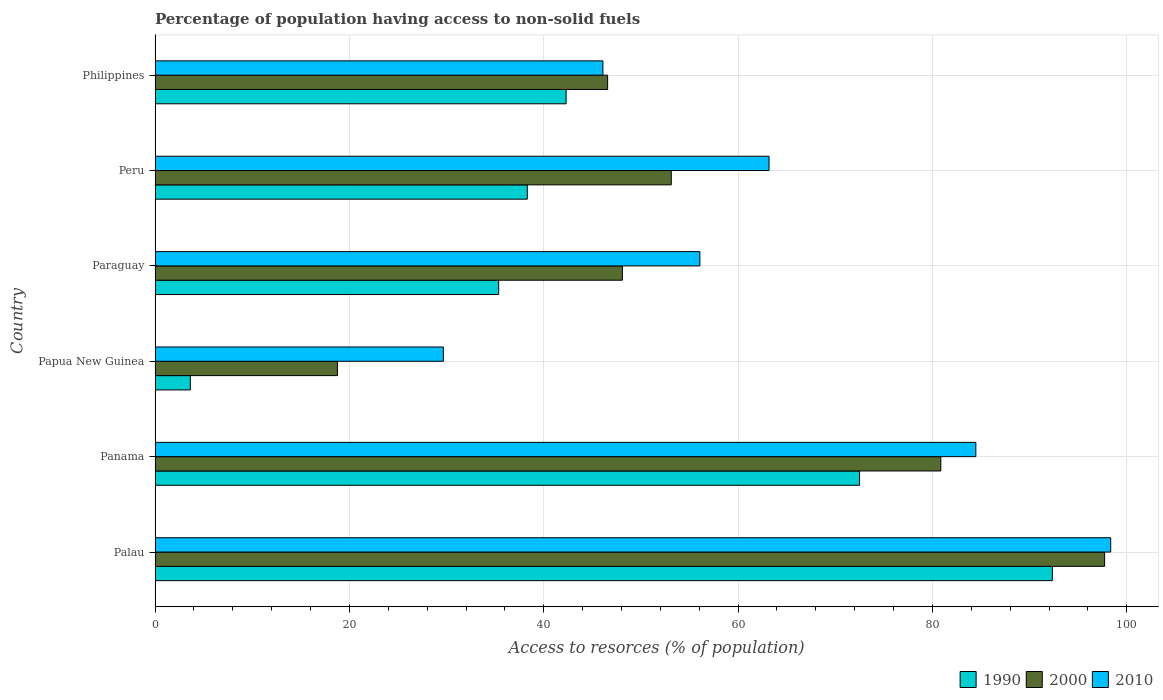How many different coloured bars are there?
Keep it short and to the point. 3. How many groups of bars are there?
Give a very brief answer. 6. Are the number of bars on each tick of the Y-axis equal?
Keep it short and to the point. Yes. How many bars are there on the 1st tick from the top?
Offer a terse response. 3. How many bars are there on the 5th tick from the bottom?
Your response must be concise. 3. What is the label of the 1st group of bars from the top?
Offer a terse response. Philippines. In how many cases, is the number of bars for a given country not equal to the number of legend labels?
Your response must be concise. 0. What is the percentage of population having access to non-solid fuels in 2000 in Peru?
Provide a succinct answer. 53.13. Across all countries, what is the maximum percentage of population having access to non-solid fuels in 2010?
Your answer should be compact. 98.35. Across all countries, what is the minimum percentage of population having access to non-solid fuels in 2010?
Your answer should be compact. 29.67. In which country was the percentage of population having access to non-solid fuels in 2010 maximum?
Ensure brevity in your answer.  Palau. In which country was the percentage of population having access to non-solid fuels in 2010 minimum?
Provide a succinct answer. Papua New Guinea. What is the total percentage of population having access to non-solid fuels in 1990 in the graph?
Keep it short and to the point. 284.46. What is the difference between the percentage of population having access to non-solid fuels in 2010 in Palau and that in Paraguay?
Make the answer very short. 42.28. What is the difference between the percentage of population having access to non-solid fuels in 1990 in Palau and the percentage of population having access to non-solid fuels in 2000 in Paraguay?
Provide a short and direct response. 44.25. What is the average percentage of population having access to non-solid fuels in 2000 per country?
Provide a short and direct response. 57.53. What is the difference between the percentage of population having access to non-solid fuels in 2010 and percentage of population having access to non-solid fuels in 2000 in Palau?
Provide a short and direct response. 0.63. What is the ratio of the percentage of population having access to non-solid fuels in 2010 in Palau to that in Philippines?
Offer a terse response. 2.13. What is the difference between the highest and the second highest percentage of population having access to non-solid fuels in 2010?
Your answer should be compact. 13.88. What is the difference between the highest and the lowest percentage of population having access to non-solid fuels in 2000?
Your answer should be compact. 78.95. What does the 3rd bar from the top in Panama represents?
Keep it short and to the point. 1990. What does the 3rd bar from the bottom in Palau represents?
Offer a very short reply. 2010. Is it the case that in every country, the sum of the percentage of population having access to non-solid fuels in 1990 and percentage of population having access to non-solid fuels in 2010 is greater than the percentage of population having access to non-solid fuels in 2000?
Provide a short and direct response. Yes. What is the difference between two consecutive major ticks on the X-axis?
Keep it short and to the point. 20. Does the graph contain any zero values?
Give a very brief answer. No. Where does the legend appear in the graph?
Your answer should be very brief. Bottom right. How many legend labels are there?
Provide a short and direct response. 3. How are the legend labels stacked?
Provide a succinct answer. Horizontal. What is the title of the graph?
Make the answer very short. Percentage of population having access to non-solid fuels. What is the label or title of the X-axis?
Ensure brevity in your answer.  Access to resorces (% of population). What is the Access to resorces (% of population) of 1990 in Palau?
Provide a short and direct response. 92.34. What is the Access to resorces (% of population) in 2000 in Palau?
Your answer should be very brief. 97.72. What is the Access to resorces (% of population) of 2010 in Palau?
Ensure brevity in your answer.  98.35. What is the Access to resorces (% of population) of 1990 in Panama?
Provide a short and direct response. 72.5. What is the Access to resorces (% of population) in 2000 in Panama?
Offer a terse response. 80.86. What is the Access to resorces (% of population) of 2010 in Panama?
Ensure brevity in your answer.  84.47. What is the Access to resorces (% of population) in 1990 in Papua New Guinea?
Keep it short and to the point. 3.63. What is the Access to resorces (% of population) in 2000 in Papua New Guinea?
Offer a very short reply. 18.77. What is the Access to resorces (% of population) of 2010 in Papua New Guinea?
Make the answer very short. 29.67. What is the Access to resorces (% of population) in 1990 in Paraguay?
Your response must be concise. 35.36. What is the Access to resorces (% of population) in 2000 in Paraguay?
Give a very brief answer. 48.09. What is the Access to resorces (% of population) in 2010 in Paraguay?
Provide a succinct answer. 56.07. What is the Access to resorces (% of population) in 1990 in Peru?
Offer a very short reply. 38.31. What is the Access to resorces (% of population) in 2000 in Peru?
Offer a very short reply. 53.13. What is the Access to resorces (% of population) in 2010 in Peru?
Your answer should be very brief. 63.19. What is the Access to resorces (% of population) in 1990 in Philippines?
Keep it short and to the point. 42.3. What is the Access to resorces (% of population) in 2000 in Philippines?
Provide a succinct answer. 46.58. What is the Access to resorces (% of population) in 2010 in Philippines?
Your answer should be very brief. 46.09. Across all countries, what is the maximum Access to resorces (% of population) in 1990?
Your answer should be very brief. 92.34. Across all countries, what is the maximum Access to resorces (% of population) in 2000?
Provide a short and direct response. 97.72. Across all countries, what is the maximum Access to resorces (% of population) of 2010?
Give a very brief answer. 98.35. Across all countries, what is the minimum Access to resorces (% of population) of 1990?
Provide a short and direct response. 3.63. Across all countries, what is the minimum Access to resorces (% of population) in 2000?
Ensure brevity in your answer.  18.77. Across all countries, what is the minimum Access to resorces (% of population) in 2010?
Make the answer very short. 29.67. What is the total Access to resorces (% of population) of 1990 in the graph?
Provide a succinct answer. 284.46. What is the total Access to resorces (% of population) of 2000 in the graph?
Your answer should be very brief. 345.15. What is the total Access to resorces (% of population) in 2010 in the graph?
Your response must be concise. 377.84. What is the difference between the Access to resorces (% of population) of 1990 in Palau and that in Panama?
Give a very brief answer. 19.84. What is the difference between the Access to resorces (% of population) in 2000 in Palau and that in Panama?
Ensure brevity in your answer.  16.86. What is the difference between the Access to resorces (% of population) in 2010 in Palau and that in Panama?
Your answer should be compact. 13.88. What is the difference between the Access to resorces (% of population) in 1990 in Palau and that in Papua New Guinea?
Your answer should be compact. 88.71. What is the difference between the Access to resorces (% of population) of 2000 in Palau and that in Papua New Guinea?
Ensure brevity in your answer.  78.95. What is the difference between the Access to resorces (% of population) of 2010 in Palau and that in Papua New Guinea?
Your answer should be compact. 68.68. What is the difference between the Access to resorces (% of population) in 1990 in Palau and that in Paraguay?
Ensure brevity in your answer.  56.98. What is the difference between the Access to resorces (% of population) in 2000 in Palau and that in Paraguay?
Make the answer very short. 49.63. What is the difference between the Access to resorces (% of population) in 2010 in Palau and that in Paraguay?
Your answer should be compact. 42.28. What is the difference between the Access to resorces (% of population) of 1990 in Palau and that in Peru?
Your response must be concise. 54.04. What is the difference between the Access to resorces (% of population) of 2000 in Palau and that in Peru?
Make the answer very short. 44.6. What is the difference between the Access to resorces (% of population) of 2010 in Palau and that in Peru?
Make the answer very short. 35.16. What is the difference between the Access to resorces (% of population) in 1990 in Palau and that in Philippines?
Provide a succinct answer. 50.04. What is the difference between the Access to resorces (% of population) of 2000 in Palau and that in Philippines?
Provide a short and direct response. 51.15. What is the difference between the Access to resorces (% of population) in 2010 in Palau and that in Philippines?
Make the answer very short. 52.26. What is the difference between the Access to resorces (% of population) of 1990 in Panama and that in Papua New Guinea?
Provide a succinct answer. 68.87. What is the difference between the Access to resorces (% of population) in 2000 in Panama and that in Papua New Guinea?
Offer a very short reply. 62.09. What is the difference between the Access to resorces (% of population) in 2010 in Panama and that in Papua New Guinea?
Your answer should be compact. 54.8. What is the difference between the Access to resorces (% of population) of 1990 in Panama and that in Paraguay?
Offer a very short reply. 37.14. What is the difference between the Access to resorces (% of population) of 2000 in Panama and that in Paraguay?
Provide a succinct answer. 32.77. What is the difference between the Access to resorces (% of population) in 2010 in Panama and that in Paraguay?
Your answer should be very brief. 28.4. What is the difference between the Access to resorces (% of population) of 1990 in Panama and that in Peru?
Offer a terse response. 34.19. What is the difference between the Access to resorces (% of population) in 2000 in Panama and that in Peru?
Your response must be concise. 27.74. What is the difference between the Access to resorces (% of population) in 2010 in Panama and that in Peru?
Offer a very short reply. 21.28. What is the difference between the Access to resorces (% of population) of 1990 in Panama and that in Philippines?
Your response must be concise. 30.2. What is the difference between the Access to resorces (% of population) in 2000 in Panama and that in Philippines?
Keep it short and to the point. 34.29. What is the difference between the Access to resorces (% of population) in 2010 in Panama and that in Philippines?
Provide a succinct answer. 38.38. What is the difference between the Access to resorces (% of population) in 1990 in Papua New Guinea and that in Paraguay?
Your answer should be compact. -31.73. What is the difference between the Access to resorces (% of population) of 2000 in Papua New Guinea and that in Paraguay?
Make the answer very short. -29.32. What is the difference between the Access to resorces (% of population) of 2010 in Papua New Guinea and that in Paraguay?
Provide a short and direct response. -26.4. What is the difference between the Access to resorces (% of population) of 1990 in Papua New Guinea and that in Peru?
Your answer should be compact. -34.68. What is the difference between the Access to resorces (% of population) in 2000 in Papua New Guinea and that in Peru?
Make the answer very short. -34.35. What is the difference between the Access to resorces (% of population) of 2010 in Papua New Guinea and that in Peru?
Provide a short and direct response. -33.52. What is the difference between the Access to resorces (% of population) of 1990 in Papua New Guinea and that in Philippines?
Your answer should be very brief. -38.67. What is the difference between the Access to resorces (% of population) of 2000 in Papua New Guinea and that in Philippines?
Make the answer very short. -27.8. What is the difference between the Access to resorces (% of population) in 2010 in Papua New Guinea and that in Philippines?
Ensure brevity in your answer.  -16.42. What is the difference between the Access to resorces (% of population) in 1990 in Paraguay and that in Peru?
Provide a succinct answer. -2.95. What is the difference between the Access to resorces (% of population) of 2000 in Paraguay and that in Peru?
Offer a very short reply. -5.03. What is the difference between the Access to resorces (% of population) of 2010 in Paraguay and that in Peru?
Make the answer very short. -7.12. What is the difference between the Access to resorces (% of population) in 1990 in Paraguay and that in Philippines?
Provide a short and direct response. -6.94. What is the difference between the Access to resorces (% of population) of 2000 in Paraguay and that in Philippines?
Your answer should be very brief. 1.52. What is the difference between the Access to resorces (% of population) of 2010 in Paraguay and that in Philippines?
Your response must be concise. 9.98. What is the difference between the Access to resorces (% of population) of 1990 in Peru and that in Philippines?
Give a very brief answer. -4. What is the difference between the Access to resorces (% of population) of 2000 in Peru and that in Philippines?
Keep it short and to the point. 6.55. What is the difference between the Access to resorces (% of population) in 2010 in Peru and that in Philippines?
Ensure brevity in your answer.  17.1. What is the difference between the Access to resorces (% of population) in 1990 in Palau and the Access to resorces (% of population) in 2000 in Panama?
Your response must be concise. 11.48. What is the difference between the Access to resorces (% of population) of 1990 in Palau and the Access to resorces (% of population) of 2010 in Panama?
Offer a very short reply. 7.87. What is the difference between the Access to resorces (% of population) in 2000 in Palau and the Access to resorces (% of population) in 2010 in Panama?
Your answer should be compact. 13.25. What is the difference between the Access to resorces (% of population) in 1990 in Palau and the Access to resorces (% of population) in 2000 in Papua New Guinea?
Ensure brevity in your answer.  73.57. What is the difference between the Access to resorces (% of population) of 1990 in Palau and the Access to resorces (% of population) of 2010 in Papua New Guinea?
Offer a very short reply. 62.67. What is the difference between the Access to resorces (% of population) in 2000 in Palau and the Access to resorces (% of population) in 2010 in Papua New Guinea?
Keep it short and to the point. 68.05. What is the difference between the Access to resorces (% of population) in 1990 in Palau and the Access to resorces (% of population) in 2000 in Paraguay?
Keep it short and to the point. 44.25. What is the difference between the Access to resorces (% of population) of 1990 in Palau and the Access to resorces (% of population) of 2010 in Paraguay?
Make the answer very short. 36.28. What is the difference between the Access to resorces (% of population) of 2000 in Palau and the Access to resorces (% of population) of 2010 in Paraguay?
Give a very brief answer. 41.65. What is the difference between the Access to resorces (% of population) of 1990 in Palau and the Access to resorces (% of population) of 2000 in Peru?
Provide a succinct answer. 39.22. What is the difference between the Access to resorces (% of population) in 1990 in Palau and the Access to resorces (% of population) in 2010 in Peru?
Your answer should be very brief. 29.16. What is the difference between the Access to resorces (% of population) of 2000 in Palau and the Access to resorces (% of population) of 2010 in Peru?
Make the answer very short. 34.54. What is the difference between the Access to resorces (% of population) in 1990 in Palau and the Access to resorces (% of population) in 2000 in Philippines?
Keep it short and to the point. 45.77. What is the difference between the Access to resorces (% of population) in 1990 in Palau and the Access to resorces (% of population) in 2010 in Philippines?
Make the answer very short. 46.26. What is the difference between the Access to resorces (% of population) of 2000 in Palau and the Access to resorces (% of population) of 2010 in Philippines?
Offer a terse response. 51.63. What is the difference between the Access to resorces (% of population) in 1990 in Panama and the Access to resorces (% of population) in 2000 in Papua New Guinea?
Your answer should be compact. 53.73. What is the difference between the Access to resorces (% of population) of 1990 in Panama and the Access to resorces (% of population) of 2010 in Papua New Guinea?
Provide a short and direct response. 42.83. What is the difference between the Access to resorces (% of population) of 2000 in Panama and the Access to resorces (% of population) of 2010 in Papua New Guinea?
Your response must be concise. 51.19. What is the difference between the Access to resorces (% of population) in 1990 in Panama and the Access to resorces (% of population) in 2000 in Paraguay?
Give a very brief answer. 24.41. What is the difference between the Access to resorces (% of population) of 1990 in Panama and the Access to resorces (% of population) of 2010 in Paraguay?
Your response must be concise. 16.43. What is the difference between the Access to resorces (% of population) in 2000 in Panama and the Access to resorces (% of population) in 2010 in Paraguay?
Make the answer very short. 24.79. What is the difference between the Access to resorces (% of population) in 1990 in Panama and the Access to resorces (% of population) in 2000 in Peru?
Your answer should be compact. 19.38. What is the difference between the Access to resorces (% of population) in 1990 in Panama and the Access to resorces (% of population) in 2010 in Peru?
Give a very brief answer. 9.31. What is the difference between the Access to resorces (% of population) of 2000 in Panama and the Access to resorces (% of population) of 2010 in Peru?
Provide a short and direct response. 17.68. What is the difference between the Access to resorces (% of population) in 1990 in Panama and the Access to resorces (% of population) in 2000 in Philippines?
Give a very brief answer. 25.93. What is the difference between the Access to resorces (% of population) in 1990 in Panama and the Access to resorces (% of population) in 2010 in Philippines?
Ensure brevity in your answer.  26.41. What is the difference between the Access to resorces (% of population) of 2000 in Panama and the Access to resorces (% of population) of 2010 in Philippines?
Offer a very short reply. 34.77. What is the difference between the Access to resorces (% of population) in 1990 in Papua New Guinea and the Access to resorces (% of population) in 2000 in Paraguay?
Your answer should be compact. -44.46. What is the difference between the Access to resorces (% of population) in 1990 in Papua New Guinea and the Access to resorces (% of population) in 2010 in Paraguay?
Offer a terse response. -52.44. What is the difference between the Access to resorces (% of population) of 2000 in Papua New Guinea and the Access to resorces (% of population) of 2010 in Paraguay?
Your response must be concise. -37.3. What is the difference between the Access to resorces (% of population) in 1990 in Papua New Guinea and the Access to resorces (% of population) in 2000 in Peru?
Provide a succinct answer. -49.49. What is the difference between the Access to resorces (% of population) of 1990 in Papua New Guinea and the Access to resorces (% of population) of 2010 in Peru?
Provide a succinct answer. -59.56. What is the difference between the Access to resorces (% of population) in 2000 in Papua New Guinea and the Access to resorces (% of population) in 2010 in Peru?
Your response must be concise. -44.42. What is the difference between the Access to resorces (% of population) in 1990 in Papua New Guinea and the Access to resorces (% of population) in 2000 in Philippines?
Your answer should be compact. -42.94. What is the difference between the Access to resorces (% of population) in 1990 in Papua New Guinea and the Access to resorces (% of population) in 2010 in Philippines?
Offer a very short reply. -42.46. What is the difference between the Access to resorces (% of population) in 2000 in Papua New Guinea and the Access to resorces (% of population) in 2010 in Philippines?
Your response must be concise. -27.32. What is the difference between the Access to resorces (% of population) of 1990 in Paraguay and the Access to resorces (% of population) of 2000 in Peru?
Ensure brevity in your answer.  -17.76. What is the difference between the Access to resorces (% of population) in 1990 in Paraguay and the Access to resorces (% of population) in 2010 in Peru?
Your answer should be compact. -27.83. What is the difference between the Access to resorces (% of population) in 2000 in Paraguay and the Access to resorces (% of population) in 2010 in Peru?
Your answer should be very brief. -15.09. What is the difference between the Access to resorces (% of population) of 1990 in Paraguay and the Access to resorces (% of population) of 2000 in Philippines?
Offer a terse response. -11.21. What is the difference between the Access to resorces (% of population) of 1990 in Paraguay and the Access to resorces (% of population) of 2010 in Philippines?
Provide a short and direct response. -10.73. What is the difference between the Access to resorces (% of population) in 2000 in Paraguay and the Access to resorces (% of population) in 2010 in Philippines?
Give a very brief answer. 2. What is the difference between the Access to resorces (% of population) of 1990 in Peru and the Access to resorces (% of population) of 2000 in Philippines?
Offer a terse response. -8.27. What is the difference between the Access to resorces (% of population) of 1990 in Peru and the Access to resorces (% of population) of 2010 in Philippines?
Ensure brevity in your answer.  -7.78. What is the difference between the Access to resorces (% of population) in 2000 in Peru and the Access to resorces (% of population) in 2010 in Philippines?
Your response must be concise. 7.04. What is the average Access to resorces (% of population) in 1990 per country?
Offer a terse response. 47.41. What is the average Access to resorces (% of population) of 2000 per country?
Offer a very short reply. 57.53. What is the average Access to resorces (% of population) of 2010 per country?
Make the answer very short. 62.97. What is the difference between the Access to resorces (% of population) of 1990 and Access to resorces (% of population) of 2000 in Palau?
Give a very brief answer. -5.38. What is the difference between the Access to resorces (% of population) in 1990 and Access to resorces (% of population) in 2010 in Palau?
Provide a succinct answer. -6.01. What is the difference between the Access to resorces (% of population) in 2000 and Access to resorces (% of population) in 2010 in Palau?
Offer a very short reply. -0.63. What is the difference between the Access to resorces (% of population) of 1990 and Access to resorces (% of population) of 2000 in Panama?
Your answer should be compact. -8.36. What is the difference between the Access to resorces (% of population) of 1990 and Access to resorces (% of population) of 2010 in Panama?
Offer a terse response. -11.97. What is the difference between the Access to resorces (% of population) in 2000 and Access to resorces (% of population) in 2010 in Panama?
Offer a very short reply. -3.61. What is the difference between the Access to resorces (% of population) in 1990 and Access to resorces (% of population) in 2000 in Papua New Guinea?
Offer a very short reply. -15.14. What is the difference between the Access to resorces (% of population) in 1990 and Access to resorces (% of population) in 2010 in Papua New Guinea?
Make the answer very short. -26.04. What is the difference between the Access to resorces (% of population) of 2000 and Access to resorces (% of population) of 2010 in Papua New Guinea?
Your answer should be compact. -10.9. What is the difference between the Access to resorces (% of population) of 1990 and Access to resorces (% of population) of 2000 in Paraguay?
Ensure brevity in your answer.  -12.73. What is the difference between the Access to resorces (% of population) of 1990 and Access to resorces (% of population) of 2010 in Paraguay?
Your answer should be very brief. -20.71. What is the difference between the Access to resorces (% of population) of 2000 and Access to resorces (% of population) of 2010 in Paraguay?
Give a very brief answer. -7.98. What is the difference between the Access to resorces (% of population) of 1990 and Access to resorces (% of population) of 2000 in Peru?
Your answer should be compact. -14.82. What is the difference between the Access to resorces (% of population) in 1990 and Access to resorces (% of population) in 2010 in Peru?
Offer a very short reply. -24.88. What is the difference between the Access to resorces (% of population) of 2000 and Access to resorces (% of population) of 2010 in Peru?
Offer a very short reply. -10.06. What is the difference between the Access to resorces (% of population) in 1990 and Access to resorces (% of population) in 2000 in Philippines?
Make the answer very short. -4.27. What is the difference between the Access to resorces (% of population) of 1990 and Access to resorces (% of population) of 2010 in Philippines?
Provide a short and direct response. -3.78. What is the difference between the Access to resorces (% of population) in 2000 and Access to resorces (% of population) in 2010 in Philippines?
Make the answer very short. 0.49. What is the ratio of the Access to resorces (% of population) of 1990 in Palau to that in Panama?
Offer a terse response. 1.27. What is the ratio of the Access to resorces (% of population) of 2000 in Palau to that in Panama?
Your answer should be compact. 1.21. What is the ratio of the Access to resorces (% of population) of 2010 in Palau to that in Panama?
Provide a succinct answer. 1.16. What is the ratio of the Access to resorces (% of population) in 1990 in Palau to that in Papua New Guinea?
Make the answer very short. 25.43. What is the ratio of the Access to resorces (% of population) in 2000 in Palau to that in Papua New Guinea?
Your answer should be very brief. 5.21. What is the ratio of the Access to resorces (% of population) of 2010 in Palau to that in Papua New Guinea?
Your response must be concise. 3.31. What is the ratio of the Access to resorces (% of population) of 1990 in Palau to that in Paraguay?
Your answer should be compact. 2.61. What is the ratio of the Access to resorces (% of population) of 2000 in Palau to that in Paraguay?
Ensure brevity in your answer.  2.03. What is the ratio of the Access to resorces (% of population) of 2010 in Palau to that in Paraguay?
Provide a short and direct response. 1.75. What is the ratio of the Access to resorces (% of population) in 1990 in Palau to that in Peru?
Your response must be concise. 2.41. What is the ratio of the Access to resorces (% of population) in 2000 in Palau to that in Peru?
Your answer should be compact. 1.84. What is the ratio of the Access to resorces (% of population) in 2010 in Palau to that in Peru?
Provide a short and direct response. 1.56. What is the ratio of the Access to resorces (% of population) of 1990 in Palau to that in Philippines?
Your answer should be very brief. 2.18. What is the ratio of the Access to resorces (% of population) in 2000 in Palau to that in Philippines?
Make the answer very short. 2.1. What is the ratio of the Access to resorces (% of population) in 2010 in Palau to that in Philippines?
Your answer should be very brief. 2.13. What is the ratio of the Access to resorces (% of population) of 1990 in Panama to that in Papua New Guinea?
Offer a terse response. 19.97. What is the ratio of the Access to resorces (% of population) in 2000 in Panama to that in Papua New Guinea?
Offer a terse response. 4.31. What is the ratio of the Access to resorces (% of population) of 2010 in Panama to that in Papua New Guinea?
Your response must be concise. 2.85. What is the ratio of the Access to resorces (% of population) in 1990 in Panama to that in Paraguay?
Give a very brief answer. 2.05. What is the ratio of the Access to resorces (% of population) in 2000 in Panama to that in Paraguay?
Make the answer very short. 1.68. What is the ratio of the Access to resorces (% of population) of 2010 in Panama to that in Paraguay?
Provide a short and direct response. 1.51. What is the ratio of the Access to resorces (% of population) of 1990 in Panama to that in Peru?
Your answer should be compact. 1.89. What is the ratio of the Access to resorces (% of population) in 2000 in Panama to that in Peru?
Your answer should be compact. 1.52. What is the ratio of the Access to resorces (% of population) in 2010 in Panama to that in Peru?
Provide a short and direct response. 1.34. What is the ratio of the Access to resorces (% of population) in 1990 in Panama to that in Philippines?
Give a very brief answer. 1.71. What is the ratio of the Access to resorces (% of population) in 2000 in Panama to that in Philippines?
Offer a terse response. 1.74. What is the ratio of the Access to resorces (% of population) in 2010 in Panama to that in Philippines?
Keep it short and to the point. 1.83. What is the ratio of the Access to resorces (% of population) in 1990 in Papua New Guinea to that in Paraguay?
Your response must be concise. 0.1. What is the ratio of the Access to resorces (% of population) of 2000 in Papua New Guinea to that in Paraguay?
Offer a very short reply. 0.39. What is the ratio of the Access to resorces (% of population) in 2010 in Papua New Guinea to that in Paraguay?
Your answer should be compact. 0.53. What is the ratio of the Access to resorces (% of population) in 1990 in Papua New Guinea to that in Peru?
Keep it short and to the point. 0.09. What is the ratio of the Access to resorces (% of population) of 2000 in Papua New Guinea to that in Peru?
Offer a terse response. 0.35. What is the ratio of the Access to resorces (% of population) in 2010 in Papua New Guinea to that in Peru?
Make the answer very short. 0.47. What is the ratio of the Access to resorces (% of population) in 1990 in Papua New Guinea to that in Philippines?
Your answer should be very brief. 0.09. What is the ratio of the Access to resorces (% of population) of 2000 in Papua New Guinea to that in Philippines?
Offer a terse response. 0.4. What is the ratio of the Access to resorces (% of population) in 2010 in Papua New Guinea to that in Philippines?
Make the answer very short. 0.64. What is the ratio of the Access to resorces (% of population) in 1990 in Paraguay to that in Peru?
Give a very brief answer. 0.92. What is the ratio of the Access to resorces (% of population) of 2000 in Paraguay to that in Peru?
Provide a succinct answer. 0.91. What is the ratio of the Access to resorces (% of population) in 2010 in Paraguay to that in Peru?
Give a very brief answer. 0.89. What is the ratio of the Access to resorces (% of population) of 1990 in Paraguay to that in Philippines?
Your response must be concise. 0.84. What is the ratio of the Access to resorces (% of population) of 2000 in Paraguay to that in Philippines?
Offer a terse response. 1.03. What is the ratio of the Access to resorces (% of population) of 2010 in Paraguay to that in Philippines?
Offer a terse response. 1.22. What is the ratio of the Access to resorces (% of population) of 1990 in Peru to that in Philippines?
Offer a terse response. 0.91. What is the ratio of the Access to resorces (% of population) in 2000 in Peru to that in Philippines?
Your answer should be compact. 1.14. What is the ratio of the Access to resorces (% of population) of 2010 in Peru to that in Philippines?
Provide a succinct answer. 1.37. What is the difference between the highest and the second highest Access to resorces (% of population) of 1990?
Ensure brevity in your answer.  19.84. What is the difference between the highest and the second highest Access to resorces (% of population) in 2000?
Make the answer very short. 16.86. What is the difference between the highest and the second highest Access to resorces (% of population) in 2010?
Offer a very short reply. 13.88. What is the difference between the highest and the lowest Access to resorces (% of population) in 1990?
Your response must be concise. 88.71. What is the difference between the highest and the lowest Access to resorces (% of population) of 2000?
Make the answer very short. 78.95. What is the difference between the highest and the lowest Access to resorces (% of population) of 2010?
Ensure brevity in your answer.  68.68. 